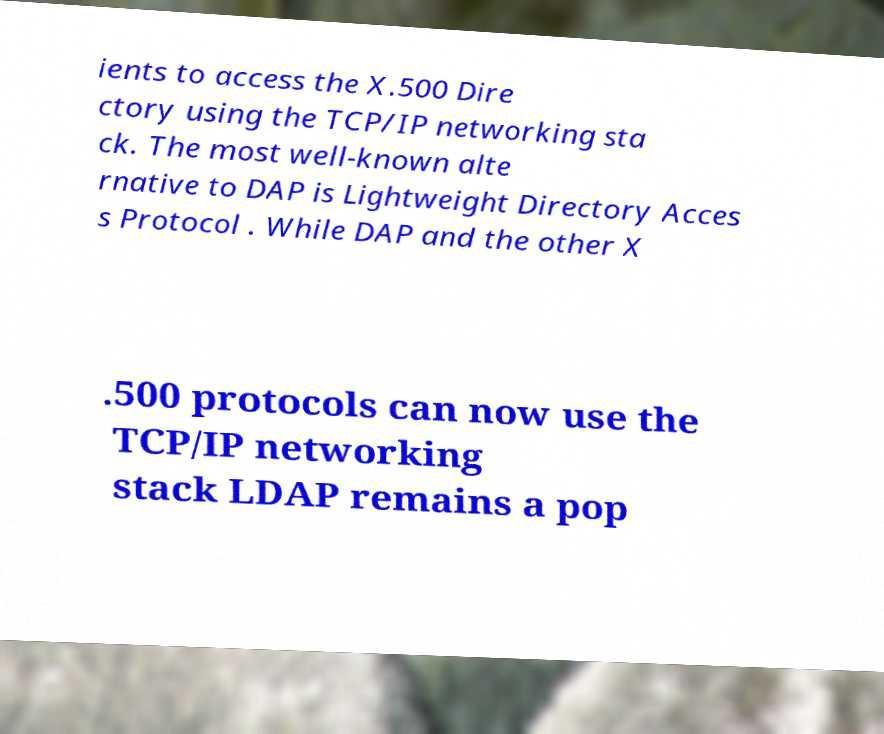Please identify and transcribe the text found in this image. ients to access the X.500 Dire ctory using the TCP/IP networking sta ck. The most well-known alte rnative to DAP is Lightweight Directory Acces s Protocol . While DAP and the other X .500 protocols can now use the TCP/IP networking stack LDAP remains a pop 